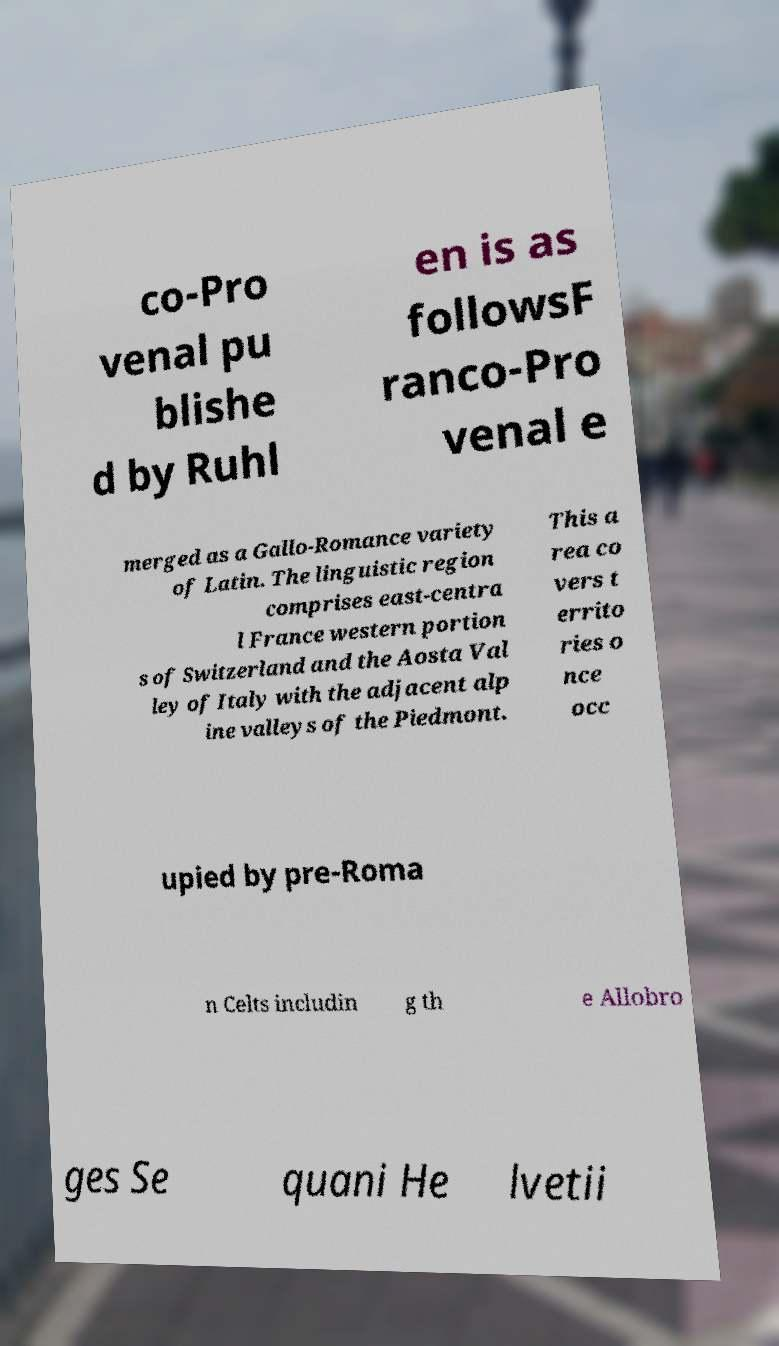Please identify and transcribe the text found in this image. co-Pro venal pu blishe d by Ruhl en is as followsF ranco-Pro venal e merged as a Gallo-Romance variety of Latin. The linguistic region comprises east-centra l France western portion s of Switzerland and the Aosta Val ley of Italy with the adjacent alp ine valleys of the Piedmont. This a rea co vers t errito ries o nce occ upied by pre-Roma n Celts includin g th e Allobro ges Se quani He lvetii 